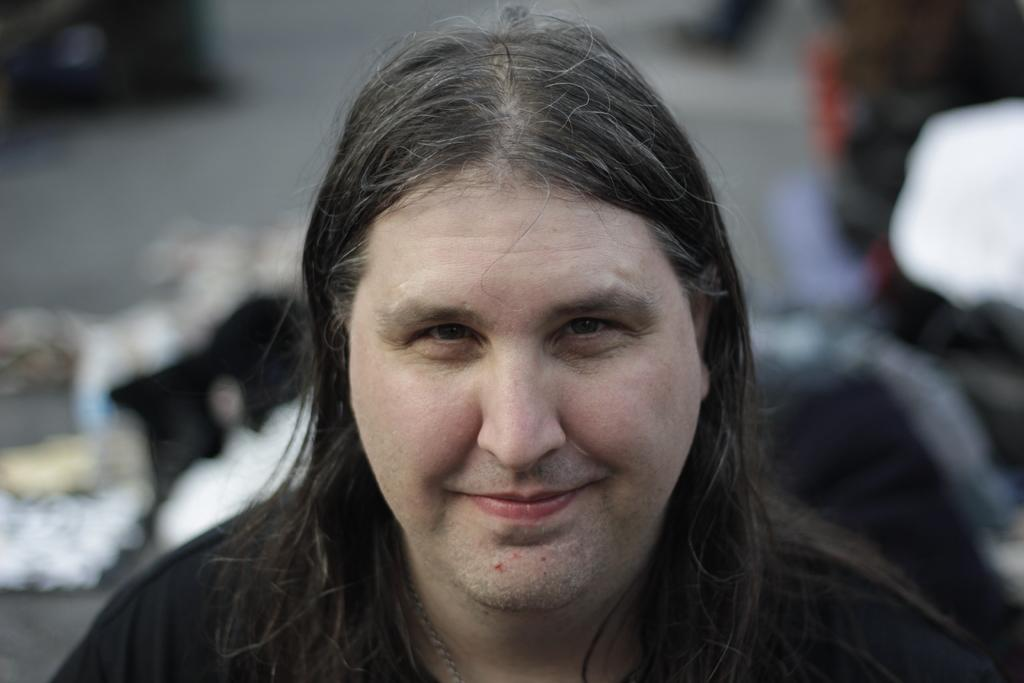What is present in the image? There is a man in the image. Can you describe the man's appearance? The man has long hair. What is the man wearing in the image? The man is wearing a black dress. What type of flesh can be seen in the image? There is no flesh visible in the image; it features a man with long hair wearing a black dress. What type of needle is the man using in the image? There is no needle present in the image. 